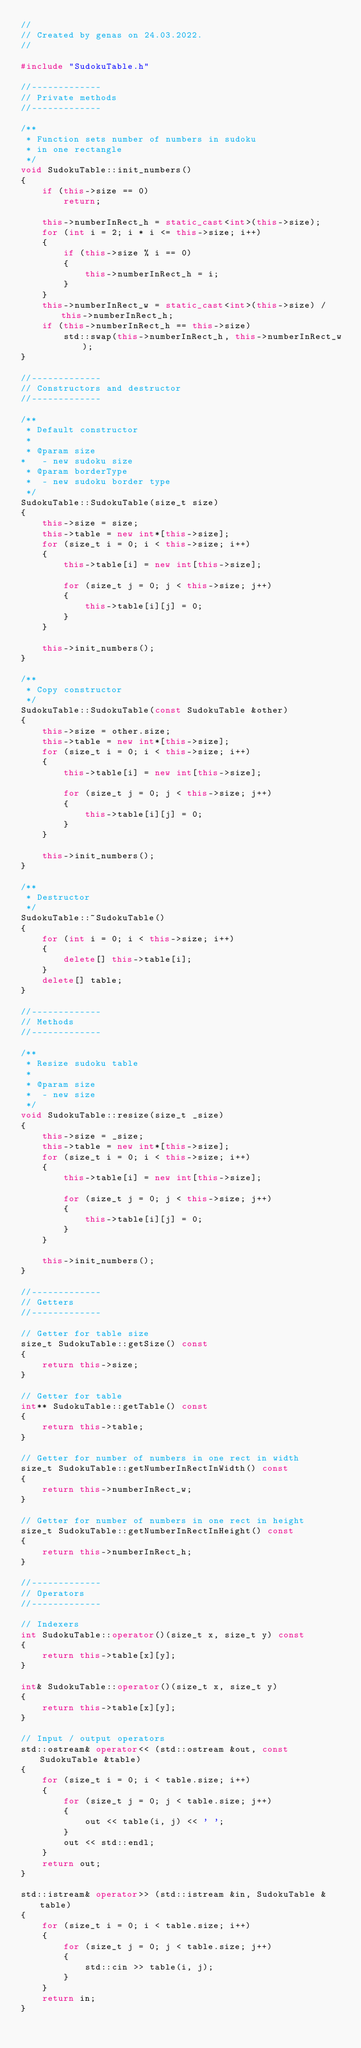Convert code to text. <code><loc_0><loc_0><loc_500><loc_500><_C++_>//
// Created by genas on 24.03.2022.
//

#include "SudokuTable.h"

//-------------
// Private methods
//-------------

/**
 * Function sets number of numbers in sudoku
 * in one rectangle
 */
void SudokuTable::init_numbers()
{
    if (this->size == 0)
        return;

    this->numberInRect_h = static_cast<int>(this->size);
    for (int i = 2; i * i <= this->size; i++)
    {
        if (this->size % i == 0)
        {
            this->numberInRect_h = i;
        }
    }
    this->numberInRect_w = static_cast<int>(this->size) / this->numberInRect_h;
    if (this->numberInRect_h == this->size)
        std::swap(this->numberInRect_h, this->numberInRect_w);
}

//-------------
// Constructors and destructor
//-------------

/**
 * Default constructor
 *
 * @param size
*   - new sudoku size
 * @param borderType
 *  - new sudoku border type
 */
SudokuTable::SudokuTable(size_t size)
{
    this->size = size;
    this->table = new int*[this->size];
    for (size_t i = 0; i < this->size; i++)
    {
        this->table[i] = new int[this->size];

        for (size_t j = 0; j < this->size; j++)
        {
            this->table[i][j] = 0;
        }
    }

    this->init_numbers();
}

/**
 * Copy constructor
 */
SudokuTable::SudokuTable(const SudokuTable &other)
{
    this->size = other.size;
    this->table = new int*[this->size];
    for (size_t i = 0; i < this->size; i++)
    {
        this->table[i] = new int[this->size];

        for (size_t j = 0; j < this->size; j++)
        {
            this->table[i][j] = 0;
        }
    }

    this->init_numbers();
}

/**
 * Destructor
 */
SudokuTable::~SudokuTable()
{
    for (int i = 0; i < this->size; i++)
    {
        delete[] this->table[i];
    }
    delete[] table;
}

//-------------
// Methods
//-------------

/**
 * Resize sudoku table
 *
 * @param size
 *  - new size
 */
void SudokuTable::resize(size_t _size)
{
    this->size = _size;
    this->table = new int*[this->size];
    for (size_t i = 0; i < this->size; i++)
    {
        this->table[i] = new int[this->size];

        for (size_t j = 0; j < this->size; j++)
        {
            this->table[i][j] = 0;
        }
    }

    this->init_numbers();
}

//-------------
// Getters
//-------------

// Getter for table size
size_t SudokuTable::getSize() const
{
    return this->size;
}

// Getter for table
int** SudokuTable::getTable() const
{
    return this->table;
}

// Getter for number of numbers in one rect in width
size_t SudokuTable::getNumberInRectInWidth() const
{
    return this->numberInRect_w;
}

// Getter for number of numbers in one rect in height
size_t SudokuTable::getNumberInRectInHeight() const
{
    return this->numberInRect_h;
}

//-------------
// Operators
//-------------

// Indexers
int SudokuTable::operator()(size_t x, size_t y) const
{
    return this->table[x][y];
}

int& SudokuTable::operator()(size_t x, size_t y)
{
    return this->table[x][y];
}

// Input / output operators
std::ostream& operator<< (std::ostream &out, const SudokuTable &table)
{
    for (size_t i = 0; i < table.size; i++)
    {
        for (size_t j = 0; j < table.size; j++)
        {
            out << table(i, j) << ' ';
        }
        out << std::endl;
    }
    return out;
}

std::istream& operator>> (std::istream &in, SudokuTable &table)
{
    for (size_t i = 0; i < table.size; i++)
    {
        for (size_t j = 0; j < table.size; j++)
        {
            std::cin >> table(i, j);
        }
    }
    return in;
}</code> 